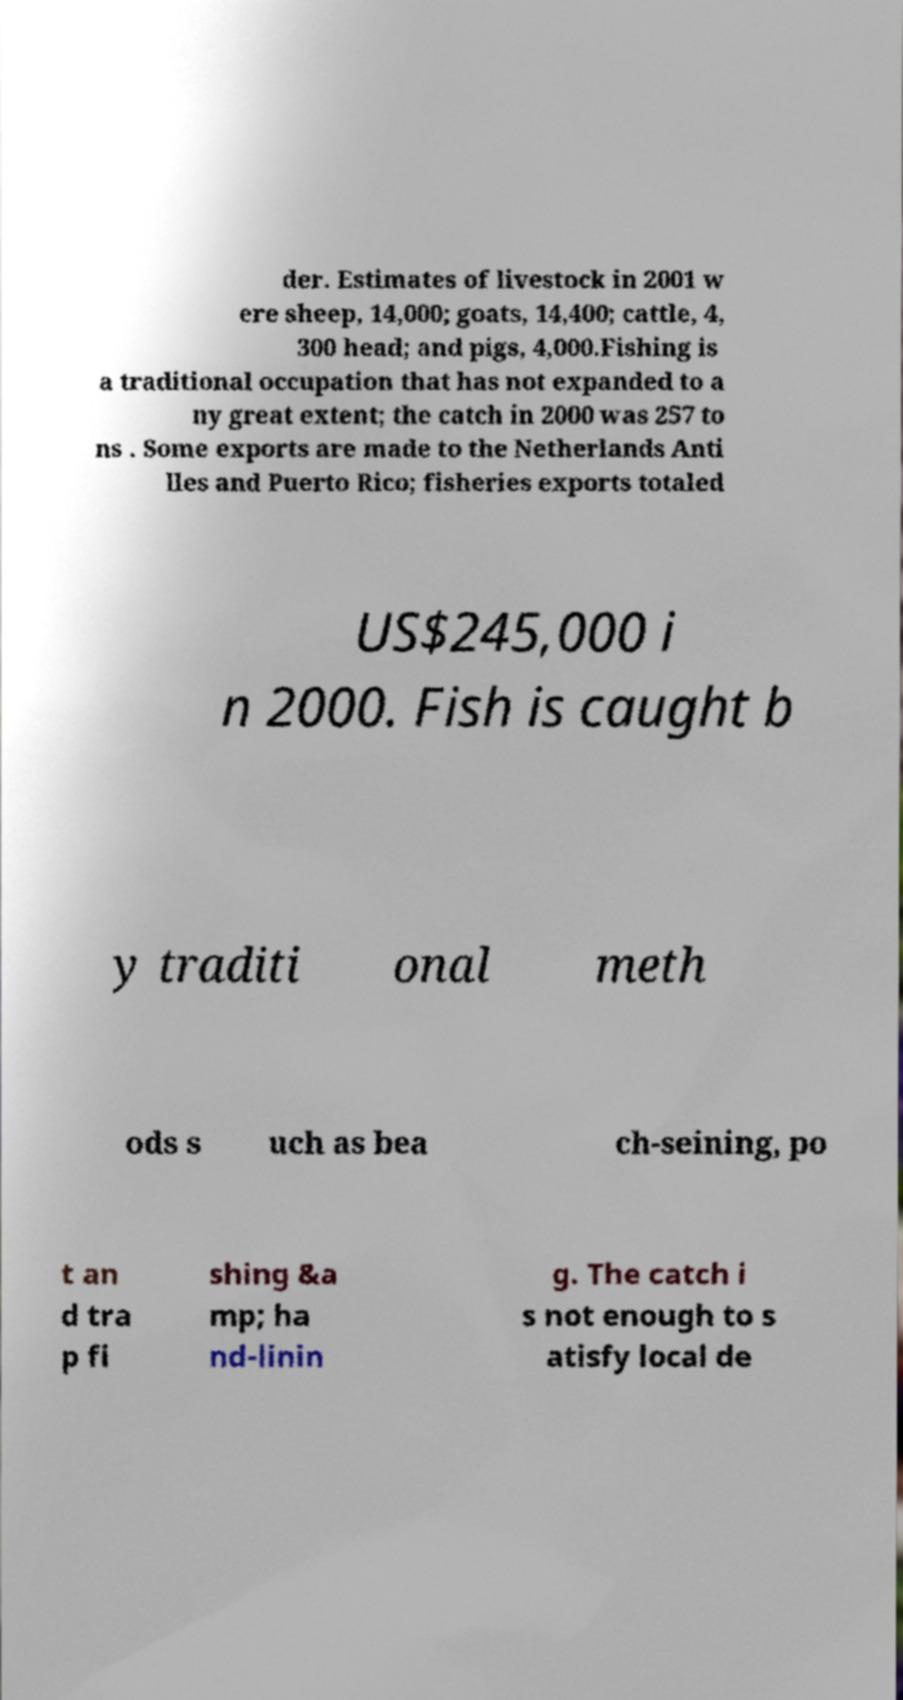Can you accurately transcribe the text from the provided image for me? der. Estimates of livestock in 2001 w ere sheep, 14,000; goats, 14,400; cattle, 4, 300 head; and pigs, 4,000.Fishing is a traditional occupation that has not expanded to a ny great extent; the catch in 2000 was 257 to ns . Some exports are made to the Netherlands Anti lles and Puerto Rico; fisheries exports totaled US$245,000 i n 2000. Fish is caught b y traditi onal meth ods s uch as bea ch-seining, po t an d tra p fi shing &a mp; ha nd-linin g. The catch i s not enough to s atisfy local de 